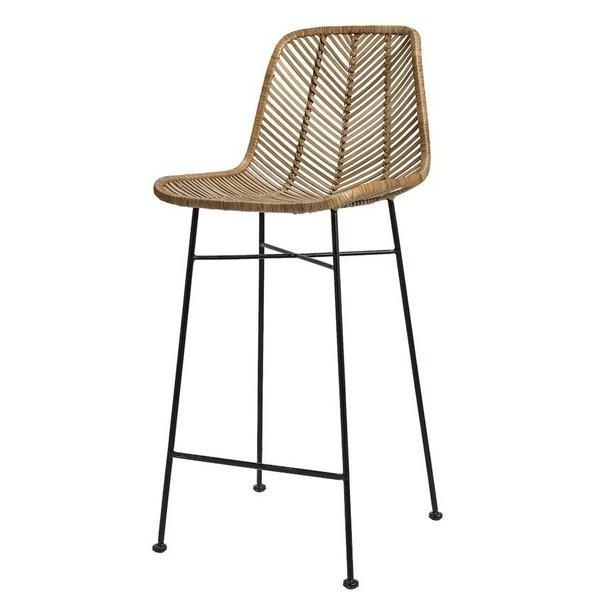What realistic scenario could involve this bar stool in a cafe setting? In a cozy, modern cafe, this bar stool would be perfect for patrons looking to enjoy a quick coffee or snack at a high-top communal table. The stool’s ergonomic design and breathable material ensure comfort during brief sittings, while its stylish appearance enhances the cafe’s welcoming ambiance. Baristas might use the stools during slower hours to engage with customers over the counter, creating a friendly and interactive environment. The durability of the rattan and metal construction ensures the stool can handle the daily hustle and bustle of cafe life, making it a practical and attractive choice for such a setting. 